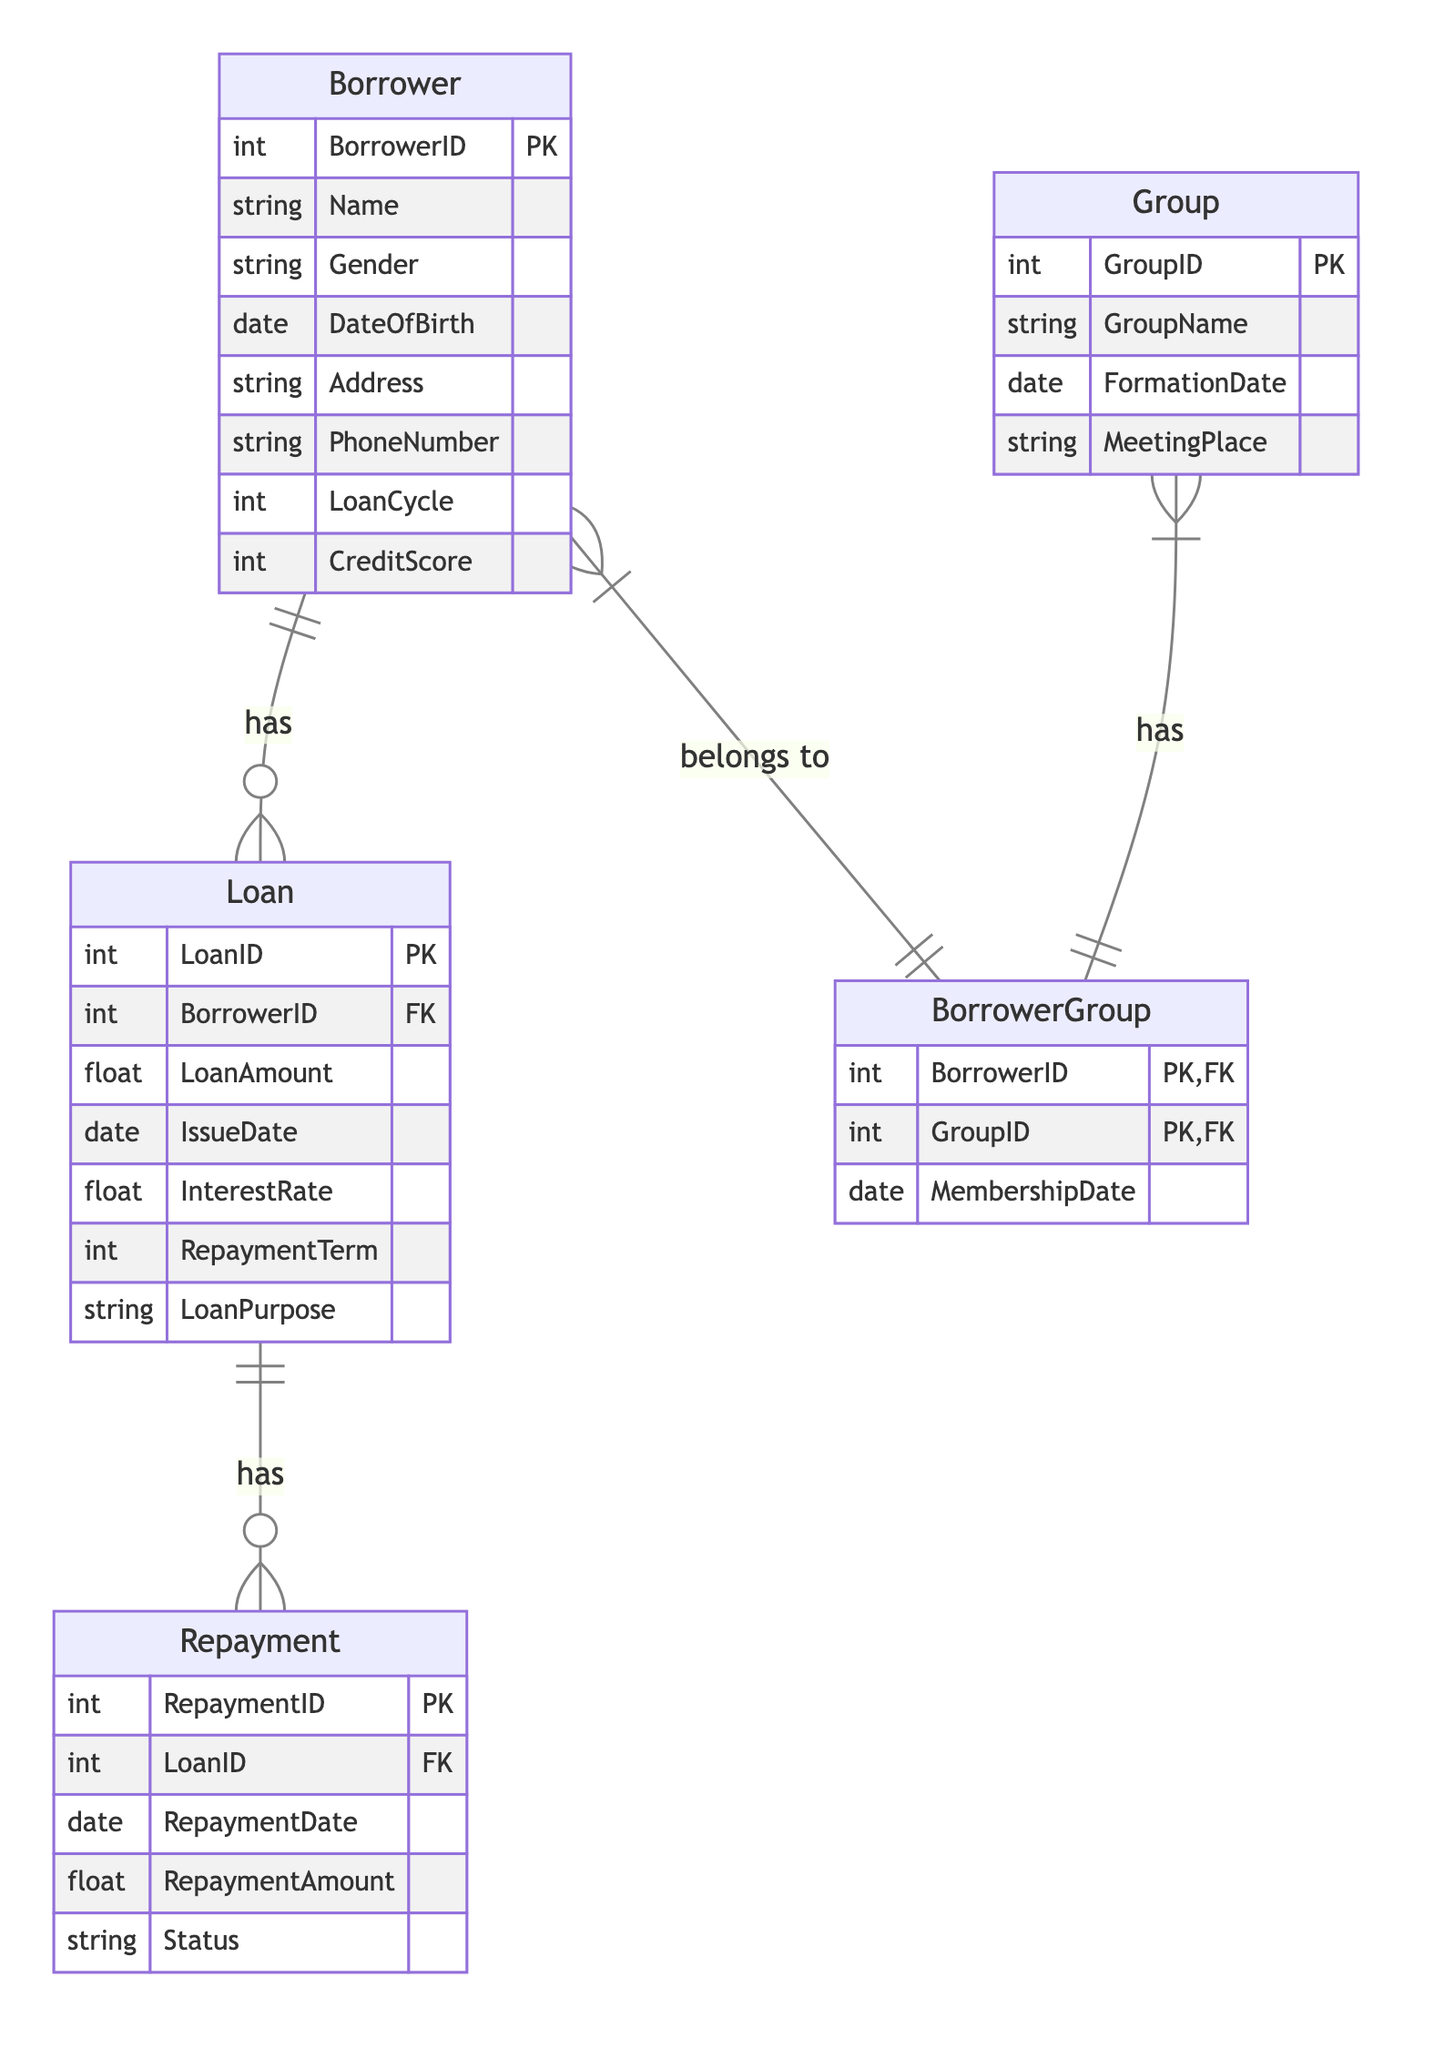What is the primary key of the Borrower entity? The primary key for the Borrower entity is BorrowerID. Looking at the attributes listed under the Borrower entity in the diagram, it is specified as the primary key.
Answer: BorrowerID How many entities are present in the diagram? To determine the number of entities, we count the unique entities listed: Borrower, Loan, Repayment, Group, and BorrowerGroup. This totals to five entities.
Answer: Five What relationship exists between Loan and Repayment? The diagram specifies a One-to-Many relationship between Loan and Repayment, indicating that a single loan can have multiple repayments associated with it.
Answer: One-to-Many How many attributes does the Repayment entity have? To find the number of attributes for the Repayment entity, we can list them: RepaymentID, LoanID, RepaymentDate, RepaymentAmount, and Status. This gives us a total of five attributes.
Answer: Five What is the foreign key in the Loan entity? In the Loan entity, the attribute designated as the foreign key is BorrowerID. This signifies that the Loan entity is connected to the Borrower entity through this key.
Answer: BorrowerID What does the BorrowerGroup relationship signify? The BorrowerGroup relationship indicates a Many-to-Many relationship between Borrower and Group. This means a borrower can belong to multiple groups, and a group can have multiple borrowers.
Answer: Many-to-Many How many primary keys does the BorrowerGroup entity have? The BorrowerGroup entity has two primary keys: BorrowerID and GroupID. This means both keys together uniquely identify records in this entity.
Answer: Two What is the primary purpose of the Loan? The primary purpose of the Loan, as indicated in the attributes, is described by the LoanPurpose attribute. This attribute specifies the specific use for which the loan was taken.
Answer: LoanPurpose What is the status of a repayment? The status of a repayment is indicated by the Status attribute in the Repayment entity, which reflects whether a repayment is complete, pending, or in default.
Answer: Status 